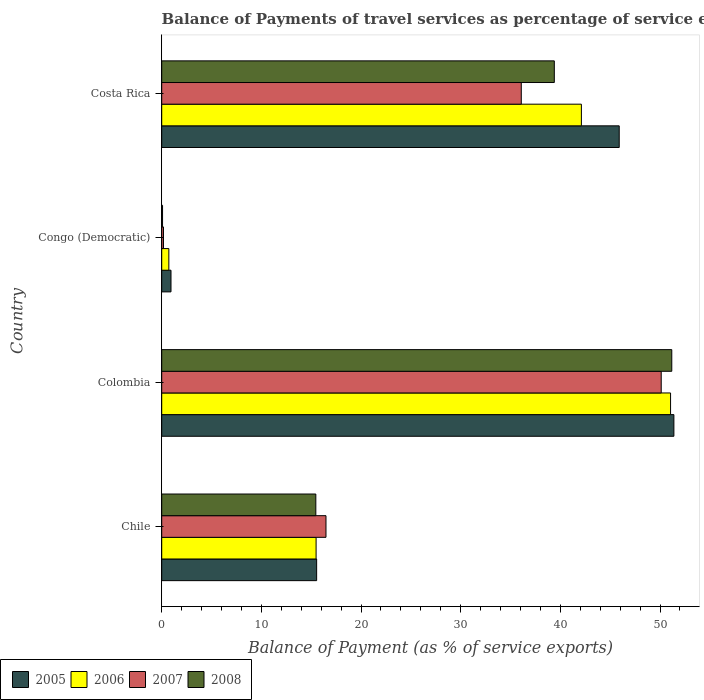How many groups of bars are there?
Your response must be concise. 4. Are the number of bars on each tick of the Y-axis equal?
Give a very brief answer. Yes. How many bars are there on the 3rd tick from the top?
Ensure brevity in your answer.  4. How many bars are there on the 4th tick from the bottom?
Give a very brief answer. 4. What is the label of the 1st group of bars from the top?
Ensure brevity in your answer.  Costa Rica. What is the balance of payments of travel services in 2008 in Colombia?
Ensure brevity in your answer.  51.18. Across all countries, what is the maximum balance of payments of travel services in 2006?
Your response must be concise. 51.06. Across all countries, what is the minimum balance of payments of travel services in 2006?
Provide a succinct answer. 0.72. In which country was the balance of payments of travel services in 2006 maximum?
Offer a terse response. Colombia. In which country was the balance of payments of travel services in 2008 minimum?
Give a very brief answer. Congo (Democratic). What is the total balance of payments of travel services in 2007 in the graph?
Ensure brevity in your answer.  102.86. What is the difference between the balance of payments of travel services in 2006 in Chile and that in Costa Rica?
Offer a very short reply. -26.62. What is the difference between the balance of payments of travel services in 2006 in Colombia and the balance of payments of travel services in 2005 in Costa Rica?
Provide a short and direct response. 5.15. What is the average balance of payments of travel services in 2005 per country?
Keep it short and to the point. 28.44. What is the difference between the balance of payments of travel services in 2006 and balance of payments of travel services in 2008 in Costa Rica?
Your response must be concise. 2.72. What is the ratio of the balance of payments of travel services in 2008 in Congo (Democratic) to that in Costa Rica?
Offer a very short reply. 0. Is the balance of payments of travel services in 2008 in Chile less than that in Costa Rica?
Make the answer very short. Yes. Is the difference between the balance of payments of travel services in 2006 in Colombia and Congo (Democratic) greater than the difference between the balance of payments of travel services in 2008 in Colombia and Congo (Democratic)?
Keep it short and to the point. No. What is the difference between the highest and the second highest balance of payments of travel services in 2008?
Provide a succinct answer. 11.79. What is the difference between the highest and the lowest balance of payments of travel services in 2007?
Your answer should be compact. 49.94. Is it the case that in every country, the sum of the balance of payments of travel services in 2005 and balance of payments of travel services in 2006 is greater than the sum of balance of payments of travel services in 2008 and balance of payments of travel services in 2007?
Give a very brief answer. No. Is it the case that in every country, the sum of the balance of payments of travel services in 2008 and balance of payments of travel services in 2007 is greater than the balance of payments of travel services in 2005?
Keep it short and to the point. No. How many bars are there?
Provide a short and direct response. 16. Are all the bars in the graph horizontal?
Your answer should be compact. Yes. How many countries are there in the graph?
Offer a terse response. 4. What is the difference between two consecutive major ticks on the X-axis?
Your answer should be very brief. 10. Are the values on the major ticks of X-axis written in scientific E-notation?
Provide a succinct answer. No. How many legend labels are there?
Your response must be concise. 4. How are the legend labels stacked?
Ensure brevity in your answer.  Horizontal. What is the title of the graph?
Offer a terse response. Balance of Payments of travel services as percentage of service exports. What is the label or title of the X-axis?
Offer a terse response. Balance of Payment (as % of service exports). What is the Balance of Payment (as % of service exports) of 2005 in Chile?
Ensure brevity in your answer.  15.55. What is the Balance of Payment (as % of service exports) of 2006 in Chile?
Your answer should be very brief. 15.49. What is the Balance of Payment (as % of service exports) in 2007 in Chile?
Offer a terse response. 16.48. What is the Balance of Payment (as % of service exports) in 2008 in Chile?
Your answer should be compact. 15.46. What is the Balance of Payment (as % of service exports) of 2005 in Colombia?
Offer a very short reply. 51.39. What is the Balance of Payment (as % of service exports) in 2006 in Colombia?
Provide a short and direct response. 51.06. What is the Balance of Payment (as % of service exports) in 2007 in Colombia?
Offer a terse response. 50.12. What is the Balance of Payment (as % of service exports) in 2008 in Colombia?
Your response must be concise. 51.18. What is the Balance of Payment (as % of service exports) in 2005 in Congo (Democratic)?
Ensure brevity in your answer.  0.93. What is the Balance of Payment (as % of service exports) in 2006 in Congo (Democratic)?
Your response must be concise. 0.72. What is the Balance of Payment (as % of service exports) of 2007 in Congo (Democratic)?
Your response must be concise. 0.18. What is the Balance of Payment (as % of service exports) in 2008 in Congo (Democratic)?
Ensure brevity in your answer.  0.08. What is the Balance of Payment (as % of service exports) of 2005 in Costa Rica?
Keep it short and to the point. 45.91. What is the Balance of Payment (as % of service exports) of 2006 in Costa Rica?
Ensure brevity in your answer.  42.11. What is the Balance of Payment (as % of service exports) in 2007 in Costa Rica?
Ensure brevity in your answer.  36.08. What is the Balance of Payment (as % of service exports) of 2008 in Costa Rica?
Your response must be concise. 39.39. Across all countries, what is the maximum Balance of Payment (as % of service exports) of 2005?
Make the answer very short. 51.39. Across all countries, what is the maximum Balance of Payment (as % of service exports) of 2006?
Offer a terse response. 51.06. Across all countries, what is the maximum Balance of Payment (as % of service exports) of 2007?
Make the answer very short. 50.12. Across all countries, what is the maximum Balance of Payment (as % of service exports) of 2008?
Offer a terse response. 51.18. Across all countries, what is the minimum Balance of Payment (as % of service exports) of 2005?
Give a very brief answer. 0.93. Across all countries, what is the minimum Balance of Payment (as % of service exports) in 2006?
Make the answer very short. 0.72. Across all countries, what is the minimum Balance of Payment (as % of service exports) of 2007?
Provide a short and direct response. 0.18. Across all countries, what is the minimum Balance of Payment (as % of service exports) of 2008?
Your response must be concise. 0.08. What is the total Balance of Payment (as % of service exports) of 2005 in the graph?
Give a very brief answer. 113.78. What is the total Balance of Payment (as % of service exports) in 2006 in the graph?
Make the answer very short. 109.38. What is the total Balance of Payment (as % of service exports) in 2007 in the graph?
Keep it short and to the point. 102.86. What is the total Balance of Payment (as % of service exports) of 2008 in the graph?
Make the answer very short. 106.12. What is the difference between the Balance of Payment (as % of service exports) of 2005 in Chile and that in Colombia?
Offer a terse response. -35.85. What is the difference between the Balance of Payment (as % of service exports) in 2006 in Chile and that in Colombia?
Give a very brief answer. -35.57. What is the difference between the Balance of Payment (as % of service exports) in 2007 in Chile and that in Colombia?
Provide a succinct answer. -33.64. What is the difference between the Balance of Payment (as % of service exports) in 2008 in Chile and that in Colombia?
Offer a very short reply. -35.72. What is the difference between the Balance of Payment (as % of service exports) of 2005 in Chile and that in Congo (Democratic)?
Provide a short and direct response. 14.61. What is the difference between the Balance of Payment (as % of service exports) of 2006 in Chile and that in Congo (Democratic)?
Offer a very short reply. 14.78. What is the difference between the Balance of Payment (as % of service exports) in 2007 in Chile and that in Congo (Democratic)?
Your answer should be very brief. 16.31. What is the difference between the Balance of Payment (as % of service exports) in 2008 in Chile and that in Congo (Democratic)?
Offer a very short reply. 15.38. What is the difference between the Balance of Payment (as % of service exports) in 2005 in Chile and that in Costa Rica?
Your answer should be very brief. -30.36. What is the difference between the Balance of Payment (as % of service exports) in 2006 in Chile and that in Costa Rica?
Provide a short and direct response. -26.62. What is the difference between the Balance of Payment (as % of service exports) in 2007 in Chile and that in Costa Rica?
Offer a very short reply. -19.6. What is the difference between the Balance of Payment (as % of service exports) in 2008 in Chile and that in Costa Rica?
Offer a terse response. -23.93. What is the difference between the Balance of Payment (as % of service exports) of 2005 in Colombia and that in Congo (Democratic)?
Your response must be concise. 50.46. What is the difference between the Balance of Payment (as % of service exports) of 2006 in Colombia and that in Congo (Democratic)?
Provide a short and direct response. 50.34. What is the difference between the Balance of Payment (as % of service exports) of 2007 in Colombia and that in Congo (Democratic)?
Keep it short and to the point. 49.94. What is the difference between the Balance of Payment (as % of service exports) in 2008 in Colombia and that in Congo (Democratic)?
Your answer should be very brief. 51.1. What is the difference between the Balance of Payment (as % of service exports) of 2005 in Colombia and that in Costa Rica?
Make the answer very short. 5.49. What is the difference between the Balance of Payment (as % of service exports) of 2006 in Colombia and that in Costa Rica?
Your answer should be very brief. 8.95. What is the difference between the Balance of Payment (as % of service exports) in 2007 in Colombia and that in Costa Rica?
Provide a succinct answer. 14.04. What is the difference between the Balance of Payment (as % of service exports) in 2008 in Colombia and that in Costa Rica?
Offer a very short reply. 11.79. What is the difference between the Balance of Payment (as % of service exports) in 2005 in Congo (Democratic) and that in Costa Rica?
Provide a short and direct response. -44.97. What is the difference between the Balance of Payment (as % of service exports) in 2006 in Congo (Democratic) and that in Costa Rica?
Your answer should be very brief. -41.4. What is the difference between the Balance of Payment (as % of service exports) in 2007 in Congo (Democratic) and that in Costa Rica?
Your answer should be compact. -35.9. What is the difference between the Balance of Payment (as % of service exports) of 2008 in Congo (Democratic) and that in Costa Rica?
Make the answer very short. -39.31. What is the difference between the Balance of Payment (as % of service exports) of 2005 in Chile and the Balance of Payment (as % of service exports) of 2006 in Colombia?
Make the answer very short. -35.51. What is the difference between the Balance of Payment (as % of service exports) in 2005 in Chile and the Balance of Payment (as % of service exports) in 2007 in Colombia?
Provide a succinct answer. -34.58. What is the difference between the Balance of Payment (as % of service exports) in 2005 in Chile and the Balance of Payment (as % of service exports) in 2008 in Colombia?
Your answer should be very brief. -35.64. What is the difference between the Balance of Payment (as % of service exports) of 2006 in Chile and the Balance of Payment (as % of service exports) of 2007 in Colombia?
Provide a succinct answer. -34.63. What is the difference between the Balance of Payment (as % of service exports) of 2006 in Chile and the Balance of Payment (as % of service exports) of 2008 in Colombia?
Keep it short and to the point. -35.69. What is the difference between the Balance of Payment (as % of service exports) in 2007 in Chile and the Balance of Payment (as % of service exports) in 2008 in Colombia?
Make the answer very short. -34.7. What is the difference between the Balance of Payment (as % of service exports) of 2005 in Chile and the Balance of Payment (as % of service exports) of 2006 in Congo (Democratic)?
Your answer should be very brief. 14.83. What is the difference between the Balance of Payment (as % of service exports) in 2005 in Chile and the Balance of Payment (as % of service exports) in 2007 in Congo (Democratic)?
Offer a terse response. 15.37. What is the difference between the Balance of Payment (as % of service exports) of 2005 in Chile and the Balance of Payment (as % of service exports) of 2008 in Congo (Democratic)?
Offer a very short reply. 15.46. What is the difference between the Balance of Payment (as % of service exports) in 2006 in Chile and the Balance of Payment (as % of service exports) in 2007 in Congo (Democratic)?
Provide a succinct answer. 15.31. What is the difference between the Balance of Payment (as % of service exports) of 2006 in Chile and the Balance of Payment (as % of service exports) of 2008 in Congo (Democratic)?
Keep it short and to the point. 15.41. What is the difference between the Balance of Payment (as % of service exports) of 2007 in Chile and the Balance of Payment (as % of service exports) of 2008 in Congo (Democratic)?
Provide a short and direct response. 16.4. What is the difference between the Balance of Payment (as % of service exports) of 2005 in Chile and the Balance of Payment (as % of service exports) of 2006 in Costa Rica?
Make the answer very short. -26.57. What is the difference between the Balance of Payment (as % of service exports) of 2005 in Chile and the Balance of Payment (as % of service exports) of 2007 in Costa Rica?
Provide a succinct answer. -20.54. What is the difference between the Balance of Payment (as % of service exports) in 2005 in Chile and the Balance of Payment (as % of service exports) in 2008 in Costa Rica?
Offer a very short reply. -23.85. What is the difference between the Balance of Payment (as % of service exports) of 2006 in Chile and the Balance of Payment (as % of service exports) of 2007 in Costa Rica?
Keep it short and to the point. -20.59. What is the difference between the Balance of Payment (as % of service exports) in 2006 in Chile and the Balance of Payment (as % of service exports) in 2008 in Costa Rica?
Provide a succinct answer. -23.9. What is the difference between the Balance of Payment (as % of service exports) in 2007 in Chile and the Balance of Payment (as % of service exports) in 2008 in Costa Rica?
Your answer should be compact. -22.91. What is the difference between the Balance of Payment (as % of service exports) in 2005 in Colombia and the Balance of Payment (as % of service exports) in 2006 in Congo (Democratic)?
Your response must be concise. 50.68. What is the difference between the Balance of Payment (as % of service exports) in 2005 in Colombia and the Balance of Payment (as % of service exports) in 2007 in Congo (Democratic)?
Provide a succinct answer. 51.21. What is the difference between the Balance of Payment (as % of service exports) in 2005 in Colombia and the Balance of Payment (as % of service exports) in 2008 in Congo (Democratic)?
Keep it short and to the point. 51.31. What is the difference between the Balance of Payment (as % of service exports) of 2006 in Colombia and the Balance of Payment (as % of service exports) of 2007 in Congo (Democratic)?
Provide a short and direct response. 50.88. What is the difference between the Balance of Payment (as % of service exports) of 2006 in Colombia and the Balance of Payment (as % of service exports) of 2008 in Congo (Democratic)?
Provide a succinct answer. 50.97. What is the difference between the Balance of Payment (as % of service exports) of 2007 in Colombia and the Balance of Payment (as % of service exports) of 2008 in Congo (Democratic)?
Ensure brevity in your answer.  50.04. What is the difference between the Balance of Payment (as % of service exports) of 2005 in Colombia and the Balance of Payment (as % of service exports) of 2006 in Costa Rica?
Provide a succinct answer. 9.28. What is the difference between the Balance of Payment (as % of service exports) in 2005 in Colombia and the Balance of Payment (as % of service exports) in 2007 in Costa Rica?
Give a very brief answer. 15.31. What is the difference between the Balance of Payment (as % of service exports) of 2005 in Colombia and the Balance of Payment (as % of service exports) of 2008 in Costa Rica?
Give a very brief answer. 12. What is the difference between the Balance of Payment (as % of service exports) of 2006 in Colombia and the Balance of Payment (as % of service exports) of 2007 in Costa Rica?
Offer a very short reply. 14.98. What is the difference between the Balance of Payment (as % of service exports) in 2006 in Colombia and the Balance of Payment (as % of service exports) in 2008 in Costa Rica?
Offer a terse response. 11.66. What is the difference between the Balance of Payment (as % of service exports) of 2007 in Colombia and the Balance of Payment (as % of service exports) of 2008 in Costa Rica?
Your response must be concise. 10.73. What is the difference between the Balance of Payment (as % of service exports) in 2005 in Congo (Democratic) and the Balance of Payment (as % of service exports) in 2006 in Costa Rica?
Your response must be concise. -41.18. What is the difference between the Balance of Payment (as % of service exports) in 2005 in Congo (Democratic) and the Balance of Payment (as % of service exports) in 2007 in Costa Rica?
Ensure brevity in your answer.  -35.15. What is the difference between the Balance of Payment (as % of service exports) of 2005 in Congo (Democratic) and the Balance of Payment (as % of service exports) of 2008 in Costa Rica?
Your response must be concise. -38.46. What is the difference between the Balance of Payment (as % of service exports) in 2006 in Congo (Democratic) and the Balance of Payment (as % of service exports) in 2007 in Costa Rica?
Your response must be concise. -35.36. What is the difference between the Balance of Payment (as % of service exports) in 2006 in Congo (Democratic) and the Balance of Payment (as % of service exports) in 2008 in Costa Rica?
Ensure brevity in your answer.  -38.68. What is the difference between the Balance of Payment (as % of service exports) of 2007 in Congo (Democratic) and the Balance of Payment (as % of service exports) of 2008 in Costa Rica?
Keep it short and to the point. -39.22. What is the average Balance of Payment (as % of service exports) of 2005 per country?
Offer a terse response. 28.44. What is the average Balance of Payment (as % of service exports) in 2006 per country?
Keep it short and to the point. 27.34. What is the average Balance of Payment (as % of service exports) in 2007 per country?
Provide a short and direct response. 25.72. What is the average Balance of Payment (as % of service exports) of 2008 per country?
Ensure brevity in your answer.  26.53. What is the difference between the Balance of Payment (as % of service exports) in 2005 and Balance of Payment (as % of service exports) in 2006 in Chile?
Make the answer very short. 0.05. What is the difference between the Balance of Payment (as % of service exports) of 2005 and Balance of Payment (as % of service exports) of 2007 in Chile?
Offer a very short reply. -0.94. What is the difference between the Balance of Payment (as % of service exports) in 2005 and Balance of Payment (as % of service exports) in 2008 in Chile?
Your response must be concise. 0.08. What is the difference between the Balance of Payment (as % of service exports) of 2006 and Balance of Payment (as % of service exports) of 2007 in Chile?
Your response must be concise. -0.99. What is the difference between the Balance of Payment (as % of service exports) in 2006 and Balance of Payment (as % of service exports) in 2008 in Chile?
Give a very brief answer. 0.03. What is the difference between the Balance of Payment (as % of service exports) in 2007 and Balance of Payment (as % of service exports) in 2008 in Chile?
Make the answer very short. 1.02. What is the difference between the Balance of Payment (as % of service exports) in 2005 and Balance of Payment (as % of service exports) in 2006 in Colombia?
Offer a very short reply. 0.33. What is the difference between the Balance of Payment (as % of service exports) in 2005 and Balance of Payment (as % of service exports) in 2007 in Colombia?
Provide a short and direct response. 1.27. What is the difference between the Balance of Payment (as % of service exports) in 2005 and Balance of Payment (as % of service exports) in 2008 in Colombia?
Ensure brevity in your answer.  0.21. What is the difference between the Balance of Payment (as % of service exports) of 2006 and Balance of Payment (as % of service exports) of 2007 in Colombia?
Give a very brief answer. 0.94. What is the difference between the Balance of Payment (as % of service exports) in 2006 and Balance of Payment (as % of service exports) in 2008 in Colombia?
Give a very brief answer. -0.12. What is the difference between the Balance of Payment (as % of service exports) in 2007 and Balance of Payment (as % of service exports) in 2008 in Colombia?
Make the answer very short. -1.06. What is the difference between the Balance of Payment (as % of service exports) of 2005 and Balance of Payment (as % of service exports) of 2006 in Congo (Democratic)?
Ensure brevity in your answer.  0.22. What is the difference between the Balance of Payment (as % of service exports) of 2005 and Balance of Payment (as % of service exports) of 2007 in Congo (Democratic)?
Offer a very short reply. 0.75. What is the difference between the Balance of Payment (as % of service exports) of 2005 and Balance of Payment (as % of service exports) of 2008 in Congo (Democratic)?
Give a very brief answer. 0.85. What is the difference between the Balance of Payment (as % of service exports) of 2006 and Balance of Payment (as % of service exports) of 2007 in Congo (Democratic)?
Give a very brief answer. 0.54. What is the difference between the Balance of Payment (as % of service exports) in 2006 and Balance of Payment (as % of service exports) in 2008 in Congo (Democratic)?
Your response must be concise. 0.63. What is the difference between the Balance of Payment (as % of service exports) in 2007 and Balance of Payment (as % of service exports) in 2008 in Congo (Democratic)?
Offer a terse response. 0.09. What is the difference between the Balance of Payment (as % of service exports) of 2005 and Balance of Payment (as % of service exports) of 2006 in Costa Rica?
Your answer should be very brief. 3.8. What is the difference between the Balance of Payment (as % of service exports) of 2005 and Balance of Payment (as % of service exports) of 2007 in Costa Rica?
Your answer should be compact. 9.83. What is the difference between the Balance of Payment (as % of service exports) in 2005 and Balance of Payment (as % of service exports) in 2008 in Costa Rica?
Your response must be concise. 6.51. What is the difference between the Balance of Payment (as % of service exports) in 2006 and Balance of Payment (as % of service exports) in 2007 in Costa Rica?
Offer a very short reply. 6.03. What is the difference between the Balance of Payment (as % of service exports) of 2006 and Balance of Payment (as % of service exports) of 2008 in Costa Rica?
Your answer should be compact. 2.72. What is the difference between the Balance of Payment (as % of service exports) of 2007 and Balance of Payment (as % of service exports) of 2008 in Costa Rica?
Offer a very short reply. -3.31. What is the ratio of the Balance of Payment (as % of service exports) in 2005 in Chile to that in Colombia?
Your answer should be very brief. 0.3. What is the ratio of the Balance of Payment (as % of service exports) in 2006 in Chile to that in Colombia?
Provide a succinct answer. 0.3. What is the ratio of the Balance of Payment (as % of service exports) of 2007 in Chile to that in Colombia?
Your answer should be very brief. 0.33. What is the ratio of the Balance of Payment (as % of service exports) of 2008 in Chile to that in Colombia?
Your answer should be compact. 0.3. What is the ratio of the Balance of Payment (as % of service exports) in 2005 in Chile to that in Congo (Democratic)?
Ensure brevity in your answer.  16.67. What is the ratio of the Balance of Payment (as % of service exports) of 2006 in Chile to that in Congo (Democratic)?
Offer a very short reply. 21.63. What is the ratio of the Balance of Payment (as % of service exports) in 2007 in Chile to that in Congo (Democratic)?
Ensure brevity in your answer.  92.4. What is the ratio of the Balance of Payment (as % of service exports) of 2008 in Chile to that in Congo (Democratic)?
Provide a succinct answer. 182.96. What is the ratio of the Balance of Payment (as % of service exports) in 2005 in Chile to that in Costa Rica?
Ensure brevity in your answer.  0.34. What is the ratio of the Balance of Payment (as % of service exports) of 2006 in Chile to that in Costa Rica?
Offer a terse response. 0.37. What is the ratio of the Balance of Payment (as % of service exports) of 2007 in Chile to that in Costa Rica?
Make the answer very short. 0.46. What is the ratio of the Balance of Payment (as % of service exports) in 2008 in Chile to that in Costa Rica?
Your answer should be very brief. 0.39. What is the ratio of the Balance of Payment (as % of service exports) in 2005 in Colombia to that in Congo (Democratic)?
Keep it short and to the point. 55.12. What is the ratio of the Balance of Payment (as % of service exports) of 2006 in Colombia to that in Congo (Democratic)?
Offer a very short reply. 71.3. What is the ratio of the Balance of Payment (as % of service exports) of 2007 in Colombia to that in Congo (Democratic)?
Give a very brief answer. 280.97. What is the ratio of the Balance of Payment (as % of service exports) in 2008 in Colombia to that in Congo (Democratic)?
Offer a very short reply. 605.54. What is the ratio of the Balance of Payment (as % of service exports) of 2005 in Colombia to that in Costa Rica?
Provide a succinct answer. 1.12. What is the ratio of the Balance of Payment (as % of service exports) in 2006 in Colombia to that in Costa Rica?
Ensure brevity in your answer.  1.21. What is the ratio of the Balance of Payment (as % of service exports) of 2007 in Colombia to that in Costa Rica?
Ensure brevity in your answer.  1.39. What is the ratio of the Balance of Payment (as % of service exports) of 2008 in Colombia to that in Costa Rica?
Make the answer very short. 1.3. What is the ratio of the Balance of Payment (as % of service exports) of 2005 in Congo (Democratic) to that in Costa Rica?
Offer a terse response. 0.02. What is the ratio of the Balance of Payment (as % of service exports) in 2006 in Congo (Democratic) to that in Costa Rica?
Keep it short and to the point. 0.02. What is the ratio of the Balance of Payment (as % of service exports) in 2007 in Congo (Democratic) to that in Costa Rica?
Provide a short and direct response. 0. What is the ratio of the Balance of Payment (as % of service exports) in 2008 in Congo (Democratic) to that in Costa Rica?
Your answer should be very brief. 0. What is the difference between the highest and the second highest Balance of Payment (as % of service exports) in 2005?
Keep it short and to the point. 5.49. What is the difference between the highest and the second highest Balance of Payment (as % of service exports) of 2006?
Offer a very short reply. 8.95. What is the difference between the highest and the second highest Balance of Payment (as % of service exports) in 2007?
Your response must be concise. 14.04. What is the difference between the highest and the second highest Balance of Payment (as % of service exports) in 2008?
Give a very brief answer. 11.79. What is the difference between the highest and the lowest Balance of Payment (as % of service exports) in 2005?
Provide a succinct answer. 50.46. What is the difference between the highest and the lowest Balance of Payment (as % of service exports) in 2006?
Give a very brief answer. 50.34. What is the difference between the highest and the lowest Balance of Payment (as % of service exports) in 2007?
Make the answer very short. 49.94. What is the difference between the highest and the lowest Balance of Payment (as % of service exports) of 2008?
Offer a very short reply. 51.1. 